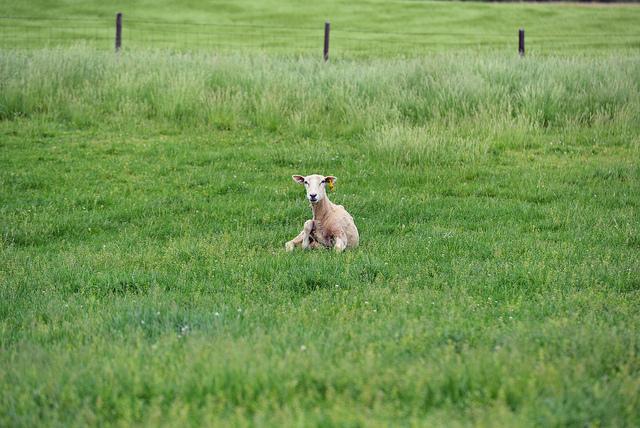How many poles do you see for the fence?
Give a very brief answer. 3. How many people are standing up?
Give a very brief answer. 0. 